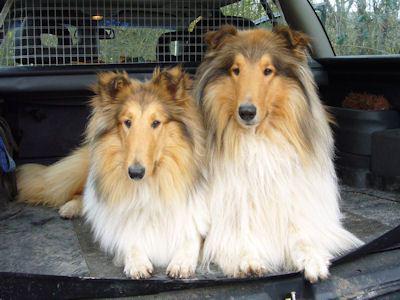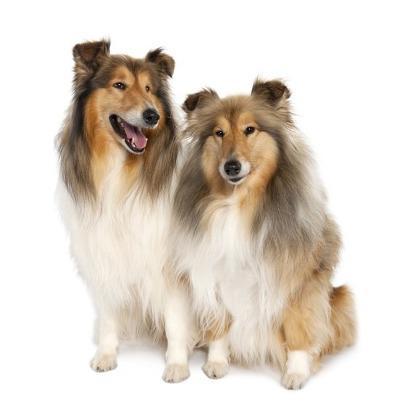The first image is the image on the left, the second image is the image on the right. Assess this claim about the two images: "There are at most three dogs.". Correct or not? Answer yes or no. No. The first image is the image on the left, the second image is the image on the right. Assess this claim about the two images: "There are no more than three dogs.". Correct or not? Answer yes or no. No. 